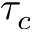Convert formula to latex. <formula><loc_0><loc_0><loc_500><loc_500>\tau _ { c }</formula> 